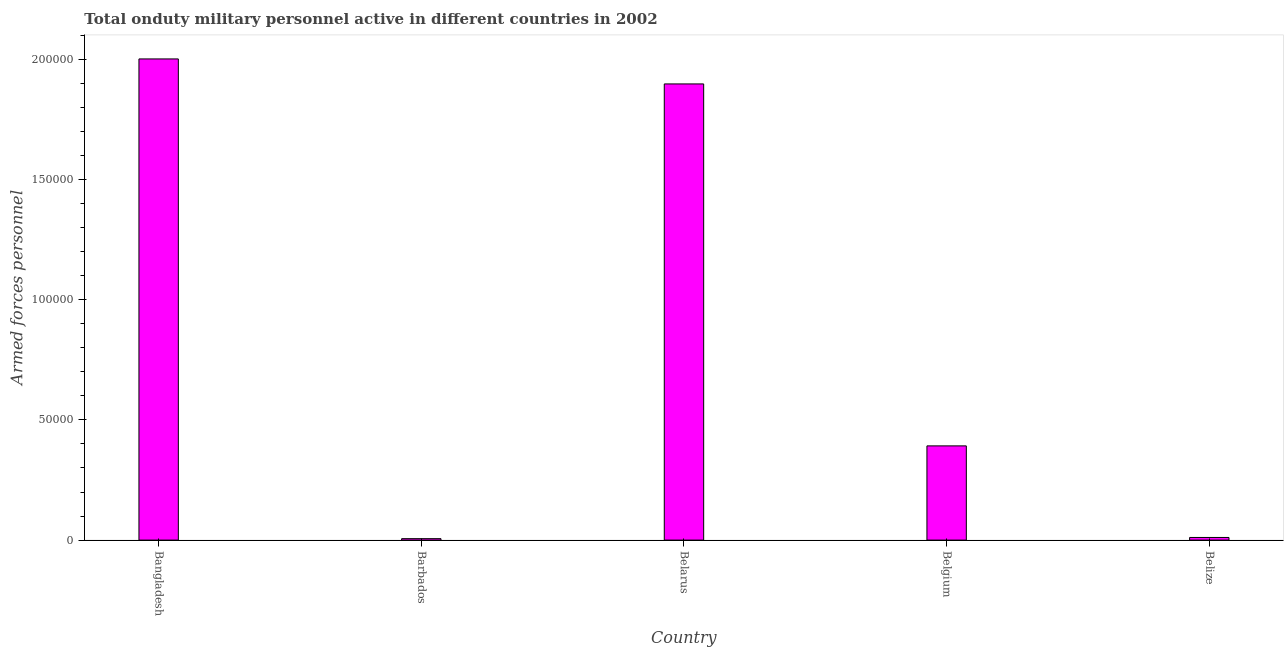What is the title of the graph?
Make the answer very short. Total onduty military personnel active in different countries in 2002. What is the label or title of the X-axis?
Your answer should be very brief. Country. What is the label or title of the Y-axis?
Your answer should be very brief. Armed forces personnel. What is the number of armed forces personnel in Belgium?
Your answer should be very brief. 3.92e+04. Across all countries, what is the maximum number of armed forces personnel?
Offer a terse response. 2.00e+05. Across all countries, what is the minimum number of armed forces personnel?
Keep it short and to the point. 600. In which country was the number of armed forces personnel maximum?
Offer a very short reply. Bangladesh. In which country was the number of armed forces personnel minimum?
Provide a short and direct response. Barbados. What is the sum of the number of armed forces personnel?
Provide a short and direct response. 4.31e+05. What is the difference between the number of armed forces personnel in Barbados and Belgium?
Your response must be concise. -3.86e+04. What is the average number of armed forces personnel per country?
Your answer should be compact. 8.62e+04. What is the median number of armed forces personnel?
Offer a very short reply. 3.92e+04. In how many countries, is the number of armed forces personnel greater than 20000 ?
Your answer should be compact. 3. What is the ratio of the number of armed forces personnel in Bangladesh to that in Barbados?
Keep it short and to the point. 333.67. Is the number of armed forces personnel in Belarus less than that in Belgium?
Provide a short and direct response. No. What is the difference between the highest and the second highest number of armed forces personnel?
Provide a succinct answer. 1.04e+04. Is the sum of the number of armed forces personnel in Bangladesh and Belgium greater than the maximum number of armed forces personnel across all countries?
Offer a very short reply. Yes. What is the difference between the highest and the lowest number of armed forces personnel?
Keep it short and to the point. 2.00e+05. In how many countries, is the number of armed forces personnel greater than the average number of armed forces personnel taken over all countries?
Make the answer very short. 2. Are all the bars in the graph horizontal?
Offer a very short reply. No. How many countries are there in the graph?
Give a very brief answer. 5. What is the Armed forces personnel in Bangladesh?
Offer a terse response. 2.00e+05. What is the Armed forces personnel in Barbados?
Give a very brief answer. 600. What is the Armed forces personnel in Belarus?
Your answer should be compact. 1.90e+05. What is the Armed forces personnel of Belgium?
Ensure brevity in your answer.  3.92e+04. What is the Armed forces personnel of Belize?
Make the answer very short. 1100. What is the difference between the Armed forces personnel in Bangladesh and Barbados?
Provide a short and direct response. 2.00e+05. What is the difference between the Armed forces personnel in Bangladesh and Belarus?
Offer a very short reply. 1.04e+04. What is the difference between the Armed forces personnel in Bangladesh and Belgium?
Offer a very short reply. 1.61e+05. What is the difference between the Armed forces personnel in Bangladesh and Belize?
Offer a very short reply. 1.99e+05. What is the difference between the Armed forces personnel in Barbados and Belarus?
Your response must be concise. -1.89e+05. What is the difference between the Armed forces personnel in Barbados and Belgium?
Your response must be concise. -3.86e+04. What is the difference between the Armed forces personnel in Barbados and Belize?
Offer a terse response. -500. What is the difference between the Armed forces personnel in Belarus and Belgium?
Offer a terse response. 1.51e+05. What is the difference between the Armed forces personnel in Belarus and Belize?
Provide a succinct answer. 1.89e+05. What is the difference between the Armed forces personnel in Belgium and Belize?
Offer a very short reply. 3.81e+04. What is the ratio of the Armed forces personnel in Bangladesh to that in Barbados?
Offer a very short reply. 333.67. What is the ratio of the Armed forces personnel in Bangladesh to that in Belarus?
Provide a short and direct response. 1.05. What is the ratio of the Armed forces personnel in Bangladesh to that in Belgium?
Offer a terse response. 5.11. What is the ratio of the Armed forces personnel in Bangladesh to that in Belize?
Your answer should be compact. 182. What is the ratio of the Armed forces personnel in Barbados to that in Belarus?
Your answer should be very brief. 0. What is the ratio of the Armed forces personnel in Barbados to that in Belgium?
Provide a succinct answer. 0.01. What is the ratio of the Armed forces personnel in Barbados to that in Belize?
Ensure brevity in your answer.  0.55. What is the ratio of the Armed forces personnel in Belarus to that in Belgium?
Make the answer very short. 4.84. What is the ratio of the Armed forces personnel in Belarus to that in Belize?
Ensure brevity in your answer.  172.54. What is the ratio of the Armed forces personnel in Belgium to that in Belize?
Offer a terse response. 35.64. 